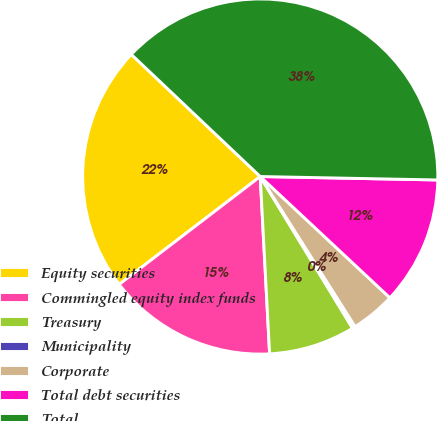Convert chart. <chart><loc_0><loc_0><loc_500><loc_500><pie_chart><fcel>Equity securities<fcel>Commingled equity index funds<fcel>Treasury<fcel>Municipality<fcel>Corporate<fcel>Total debt securities<fcel>Total<nl><fcel>22.46%<fcel>15.45%<fcel>7.86%<fcel>0.27%<fcel>4.06%<fcel>11.66%<fcel>38.24%<nl></chart> 